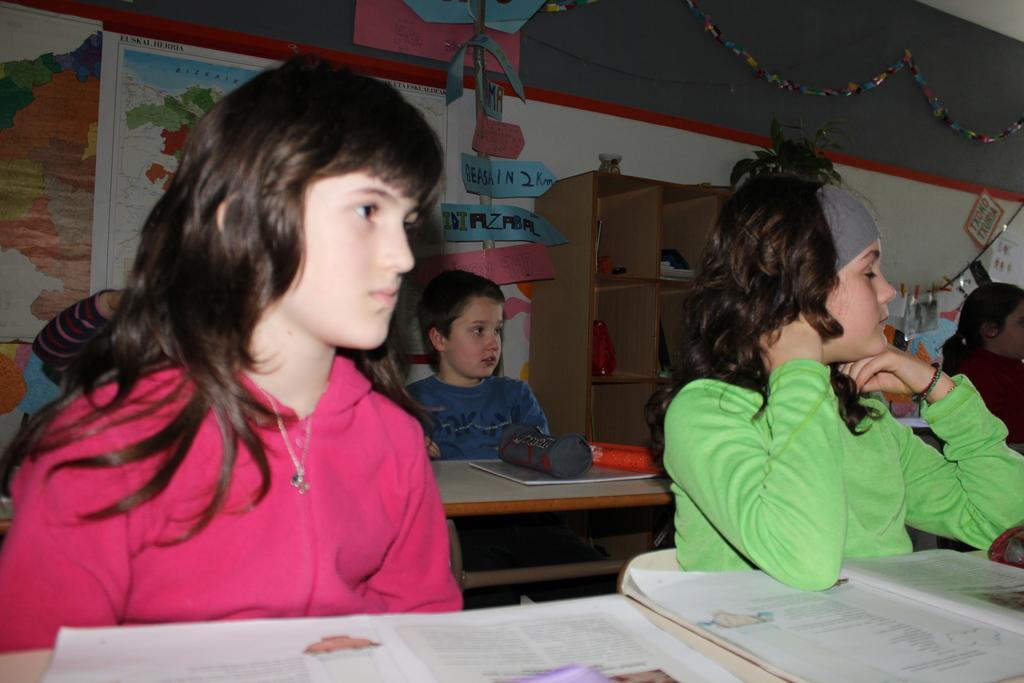Describe this image in one or two sentences. In the image we can see there are people who are sitting on chair and on table there are books and on the wall there is poster of poster of a map and there are decorations which are done on the wall on the back. 